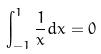Convert formula to latex. <formula><loc_0><loc_0><loc_500><loc_500>\int _ { - 1 } ^ { 1 } \frac { 1 } { x } d x = 0</formula> 